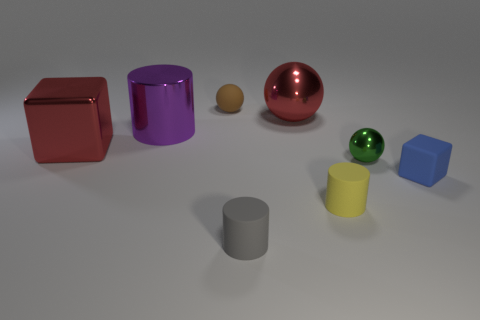Add 1 tiny matte cylinders. How many objects exist? 9 Subtract all cubes. How many objects are left? 6 Subtract all yellow matte things. Subtract all matte things. How many objects are left? 3 Add 7 tiny rubber cylinders. How many tiny rubber cylinders are left? 9 Add 1 tiny gray rubber cylinders. How many tiny gray rubber cylinders exist? 2 Subtract 1 green balls. How many objects are left? 7 